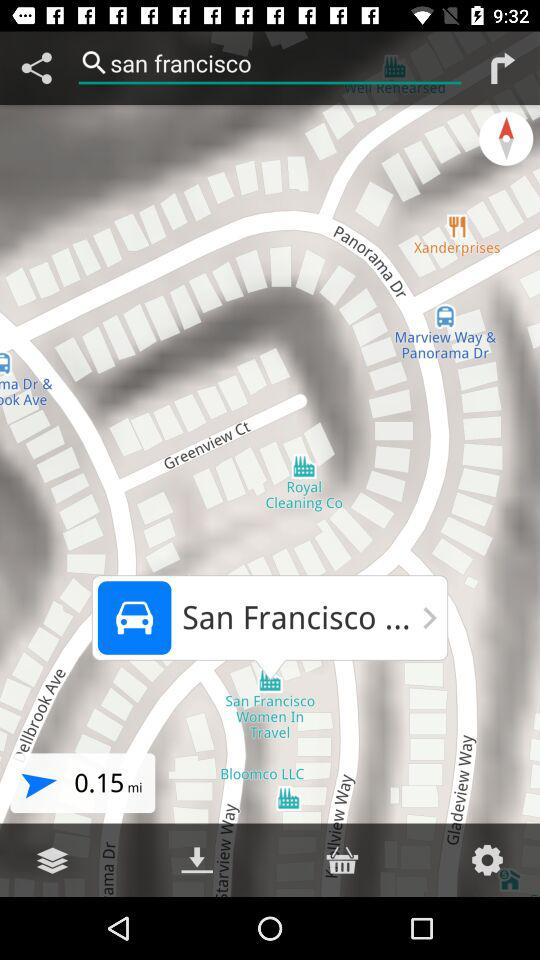What is the searched location? The searched location is San Francisco. 